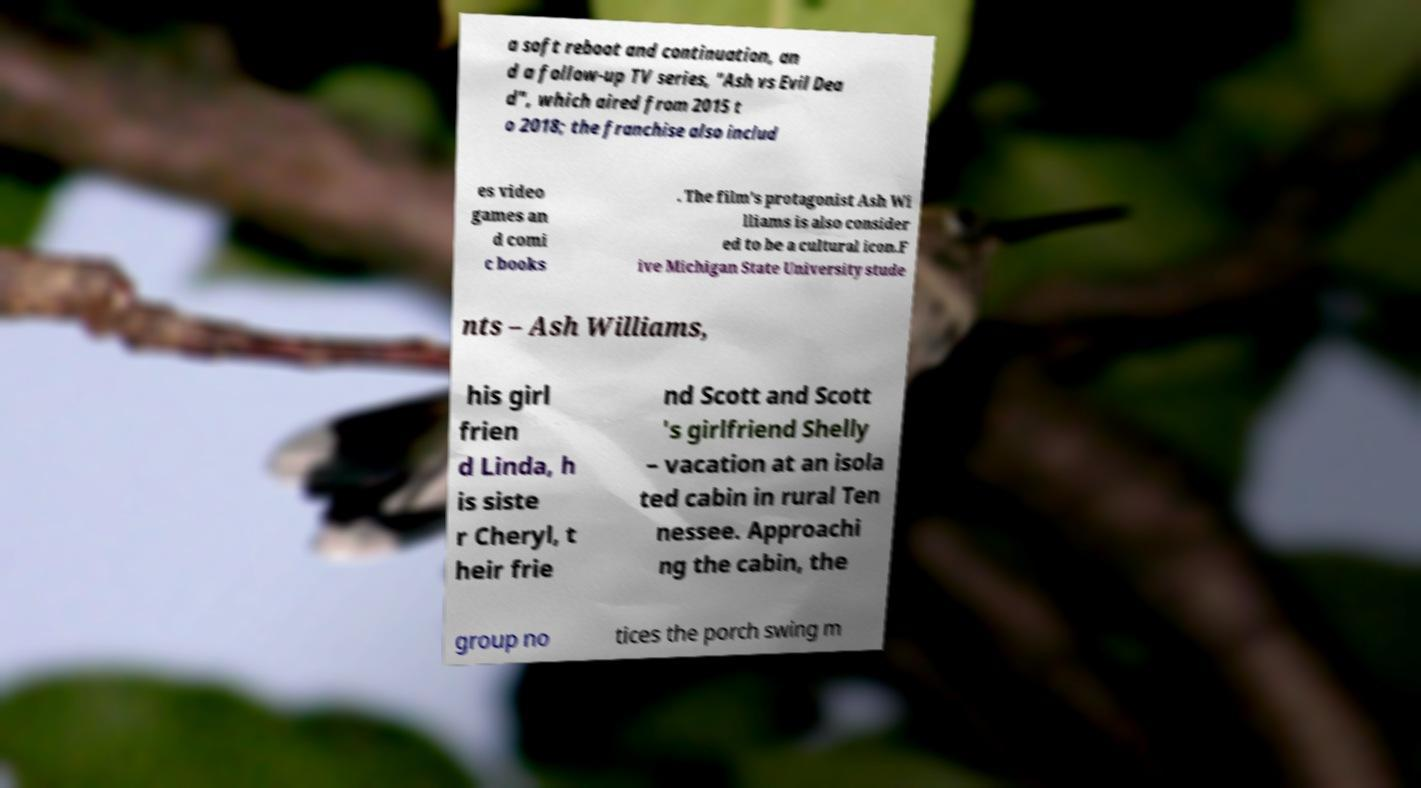Can you read and provide the text displayed in the image?This photo seems to have some interesting text. Can you extract and type it out for me? a soft reboot and continuation, an d a follow-up TV series, "Ash vs Evil Dea d", which aired from 2015 t o 2018; the franchise also includ es video games an d comi c books . The film's protagonist Ash Wi lliams is also consider ed to be a cultural icon.F ive Michigan State University stude nts – Ash Williams, his girl frien d Linda, h is siste r Cheryl, t heir frie nd Scott and Scott 's girlfriend Shelly – vacation at an isola ted cabin in rural Ten nessee. Approachi ng the cabin, the group no tices the porch swing m 